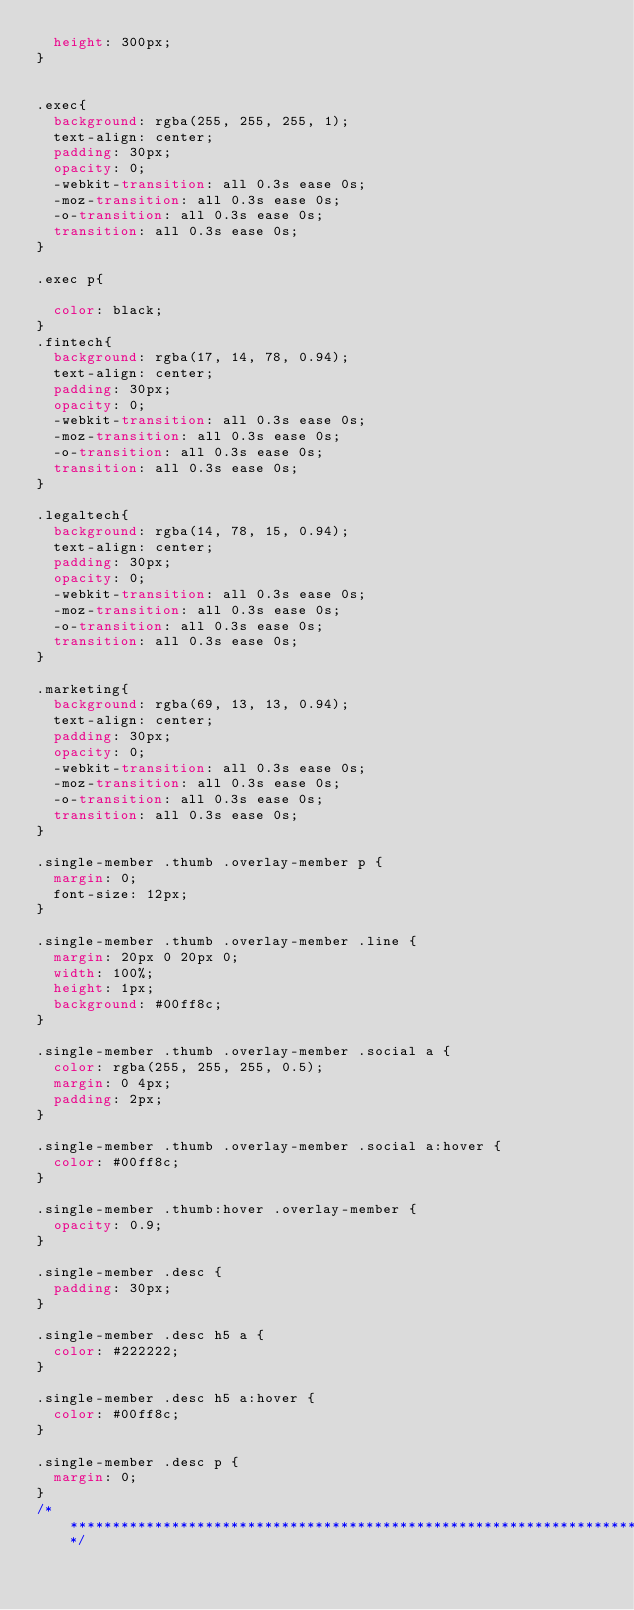<code> <loc_0><loc_0><loc_500><loc_500><_CSS_>  height: 300px;
}


.exec{
  background: rgba(255, 255, 255, 1);
  text-align: center;
  padding: 30px;
  opacity: 0;
  -webkit-transition: all 0.3s ease 0s;
  -moz-transition: all 0.3s ease 0s;
  -o-transition: all 0.3s ease 0s;
  transition: all 0.3s ease 0s;
}

.exec p{

  color: black;
}
.fintech{
  background: rgba(17, 14, 78, 0.94);
  text-align: center;
  padding: 30px;
  opacity: 0;
  -webkit-transition: all 0.3s ease 0s;
  -moz-transition: all 0.3s ease 0s;
  -o-transition: all 0.3s ease 0s;
  transition: all 0.3s ease 0s;
}

.legaltech{
  background: rgba(14, 78, 15, 0.94);
  text-align: center;
  padding: 30px;
  opacity: 0;
  -webkit-transition: all 0.3s ease 0s;
  -moz-transition: all 0.3s ease 0s;
  -o-transition: all 0.3s ease 0s;
  transition: all 0.3s ease 0s;
}

.marketing{
  background: rgba(69, 13, 13, 0.94);
  text-align: center;
  padding: 30px;
  opacity: 0;
  -webkit-transition: all 0.3s ease 0s;
  -moz-transition: all 0.3s ease 0s;
  -o-transition: all 0.3s ease 0s;
  transition: all 0.3s ease 0s;
}

.single-member .thumb .overlay-member p {
  margin: 0;
  font-size: 12px;
}

.single-member .thumb .overlay-member .line {
  margin: 20px 0 20px 0;
  width: 100%;
  height: 1px;
  background: #00ff8c;
}

.single-member .thumb .overlay-member .social a {
  color: rgba(255, 255, 255, 0.5);
  margin: 0 4px;
  padding: 2px;
}

.single-member .thumb .overlay-member .social a:hover {
  color: #00ff8c;
}

.single-member .thumb:hover .overlay-member {
  opacity: 0.9;
}

.single-member .desc {
  padding: 30px;
}

.single-member .desc h5 a {
  color: #222222;
}

.single-member .desc h5 a:hover {
  color: #00ff8c;
}

.single-member .desc p {
  margin: 0;
}
/*****************************************************************************************/
</code> 